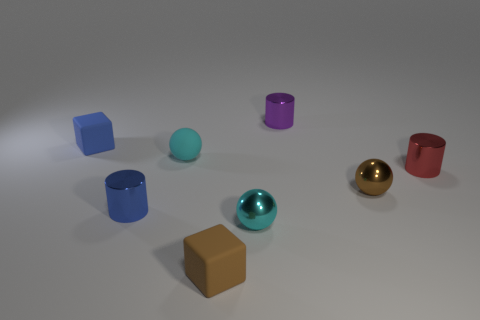Are there any other things that are the same material as the small purple cylinder?
Your answer should be very brief. Yes. There is a object that is both in front of the small brown metallic sphere and on the left side of the small matte sphere; what is its material?
Offer a terse response. Metal. What shape is the brown thing that is the same material as the blue cylinder?
Your response must be concise. Sphere. Is there any other thing of the same color as the matte ball?
Keep it short and to the point. Yes. Are there more small cyan rubber spheres to the right of the brown matte thing than metallic spheres?
Give a very brief answer. No. What is the tiny blue cube made of?
Offer a very short reply. Rubber. How many red things have the same size as the matte ball?
Keep it short and to the point. 1. Are there the same number of things behind the tiny blue metallic cylinder and cyan matte objects that are left of the red thing?
Provide a short and direct response. No. Does the tiny purple cylinder have the same material as the brown cube?
Your response must be concise. No. There is a tiny cube that is behind the blue metallic thing; is there a tiny brown cube that is behind it?
Offer a terse response. No. 